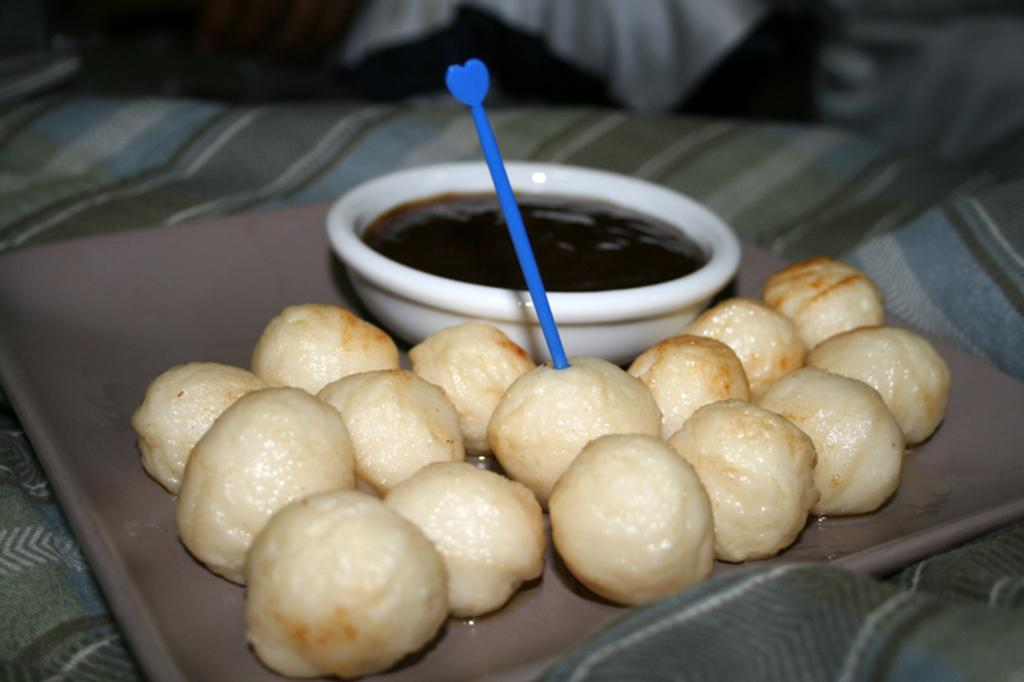What type of items can be seen in the image? There are eatables in the image. What is the primary container for the eatables? There is a bowl in the image. What is inside the bowl? There is something in the bowl. What time of day is it in the image, and is there a scarecrow present? The time of day is not mentioned in the image, and there is no scarecrow present. 